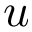Convert formula to latex. <formula><loc_0><loc_0><loc_500><loc_500>u</formula> 